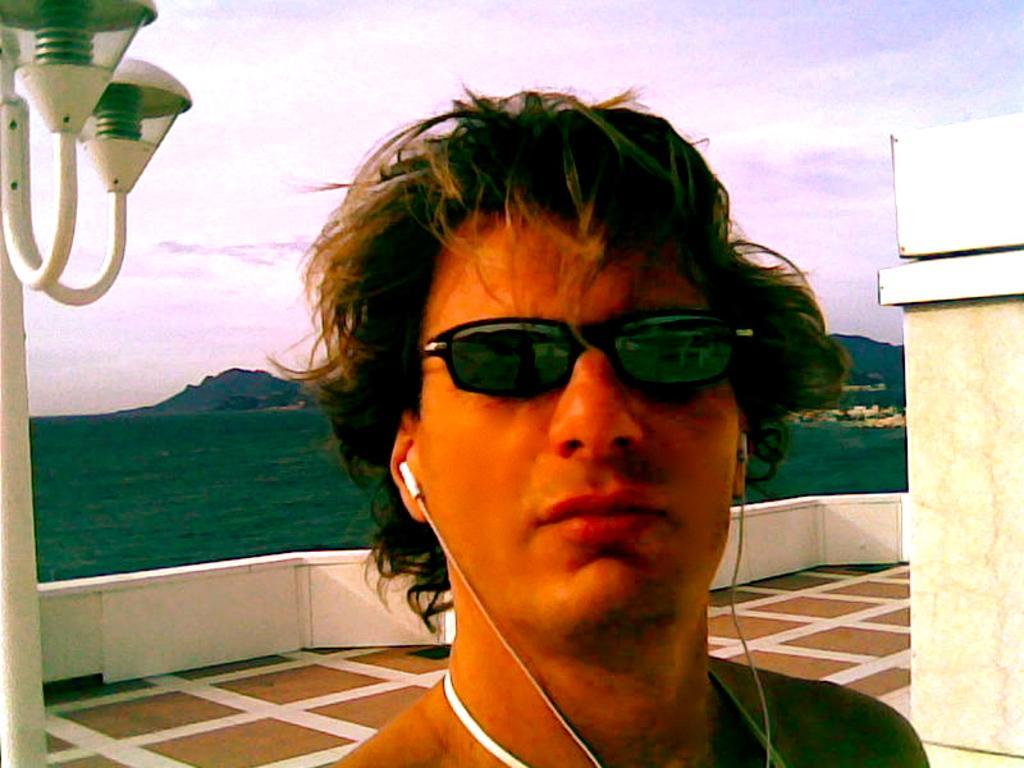Can you describe this image briefly? In this image there is a man, on the left side there is a light pole, on the right there is a wall, in the background there is green land and mountains and a sky. 